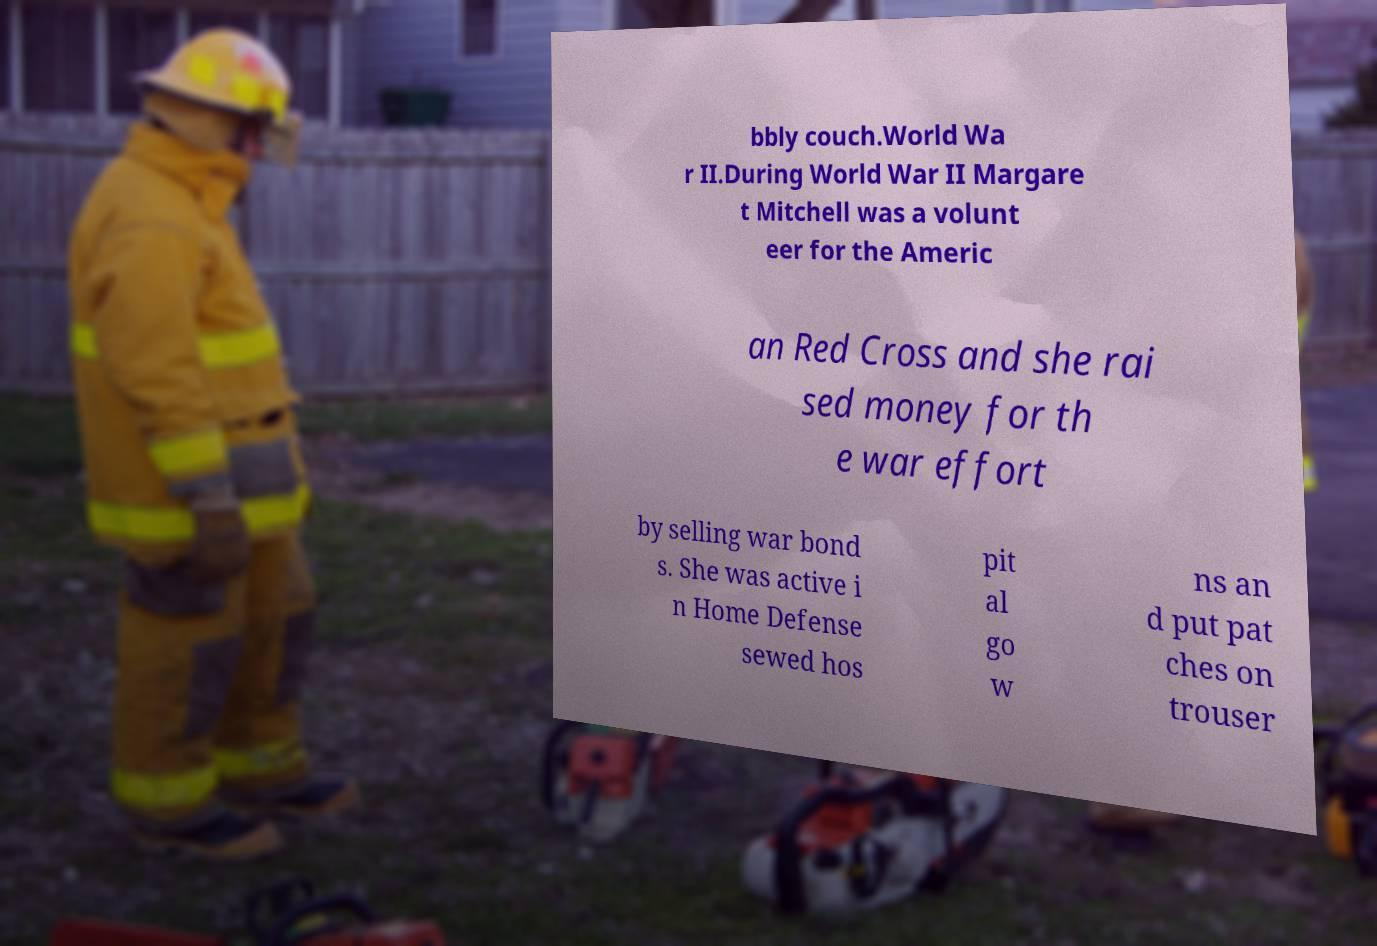Please read and relay the text visible in this image. What does it say? bbly couch.World Wa r II.During World War II Margare t Mitchell was a volunt eer for the Americ an Red Cross and she rai sed money for th e war effort by selling war bond s. She was active i n Home Defense sewed hos pit al go w ns an d put pat ches on trouser 